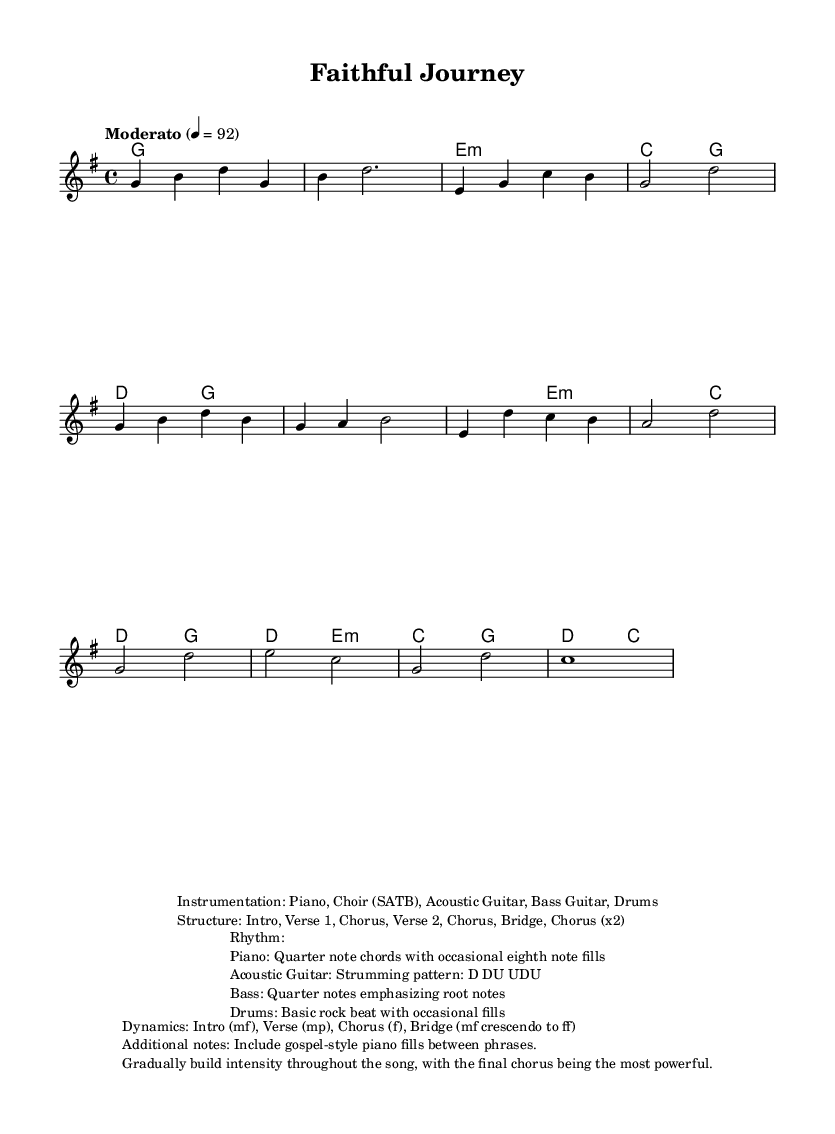What is the key signature of this music? The key signature is G major, which has one sharp (F#). This can be determined by looking at the key signature indicated at the beginning of the staff.
Answer: G major What is the time signature? The time signature is 4/4, as indicated at the beginning of the score. This means there are four beats in each measure, and each quarter note gets one beat.
Answer: 4/4 What is the tempo marking? The tempo marking is "Moderato" set at 92 beats per minute. This is indicated at the beginning of the score and provides guidance on the speed of the piece.
Answer: Moderato, 92 How many sections are there in the structure? The structure includes seven distinct sections: Intro, Verse 1, Chorus, Verse 2, Chorus, Bridge, and Chorus (x2). This is noted in the additional markings provided in the score.
Answer: Seven Which instruments are used in this piece? The instrumentation list includes Piano, Choir (SATB), Acoustic Guitar, Bass Guitar, and Drums. This information is provided in the markup section detailing the instrumentation.
Answer: Piano, Choir (SATB), Acoustic Guitar, Bass Guitar, Drums During which section does the intensity build to a fortissimo? The intensity builds to a fortissimo during the final chorus of the composition, as indicated in the dynamics marking section of the score detailing the crescendo.
Answer: Final Chorus 